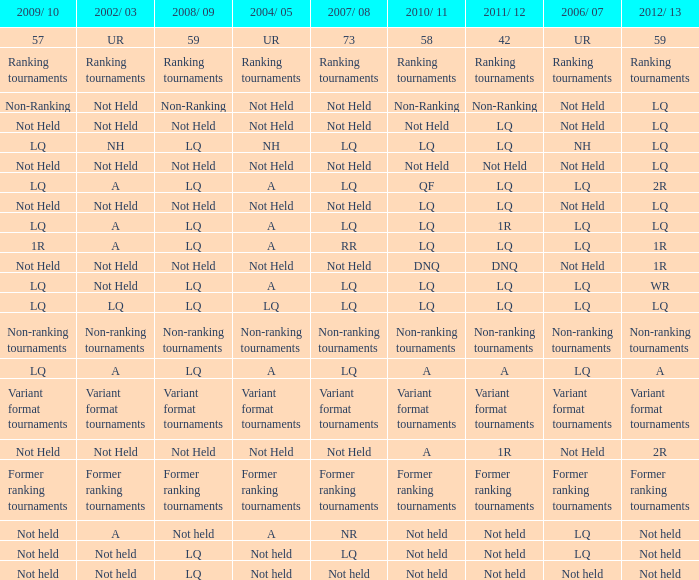Name the 2008/09 with 2004/05 of ranking tournaments Ranking tournaments. 